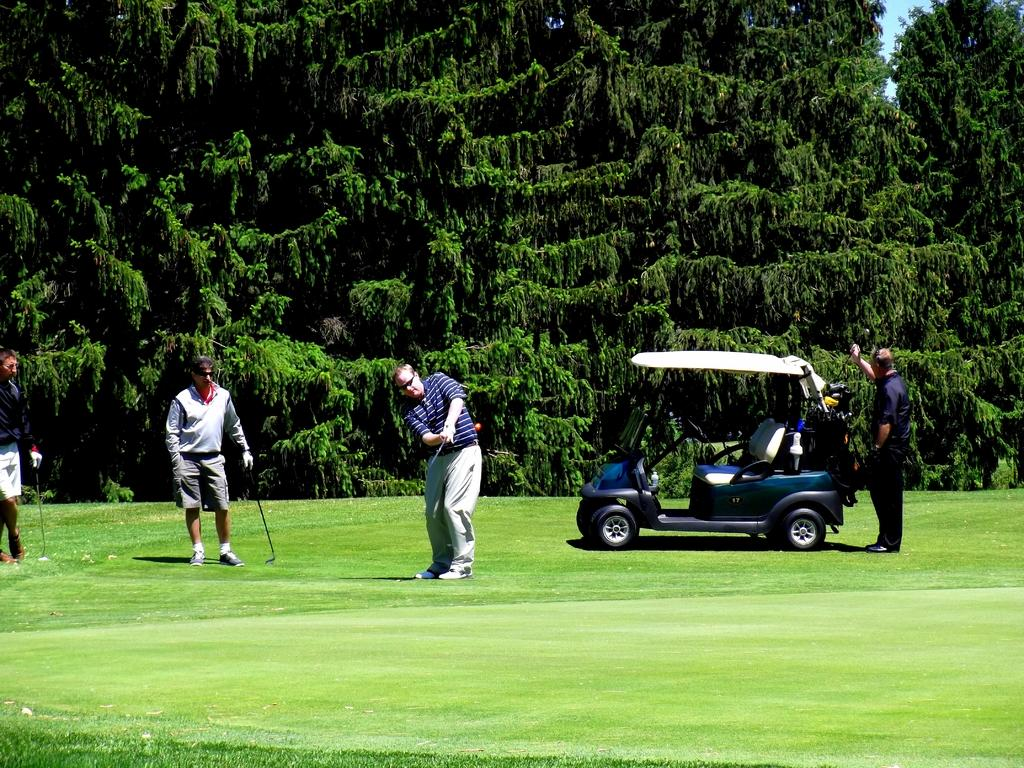What can be seen in the front of the image? There are people and a vehicle in the front of the image. What are the people holding in the image? Three people are holding sticks in the image. What type of vegetation is present in the front of the image? There is grass in the front of the image. What can be seen in the background of the image? There are trees in the background of the image. What type of hen can be seen in the image? There is no hen present in the image. Is the image set during the winter season? The provided facts do not mention any specific season or weather conditions, so it cannot be determined if the image is set during winter. 